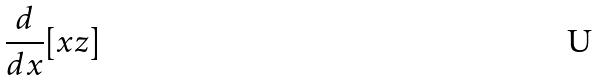Convert formula to latex. <formula><loc_0><loc_0><loc_500><loc_500>\frac { d } { d x } [ x z ]</formula> 